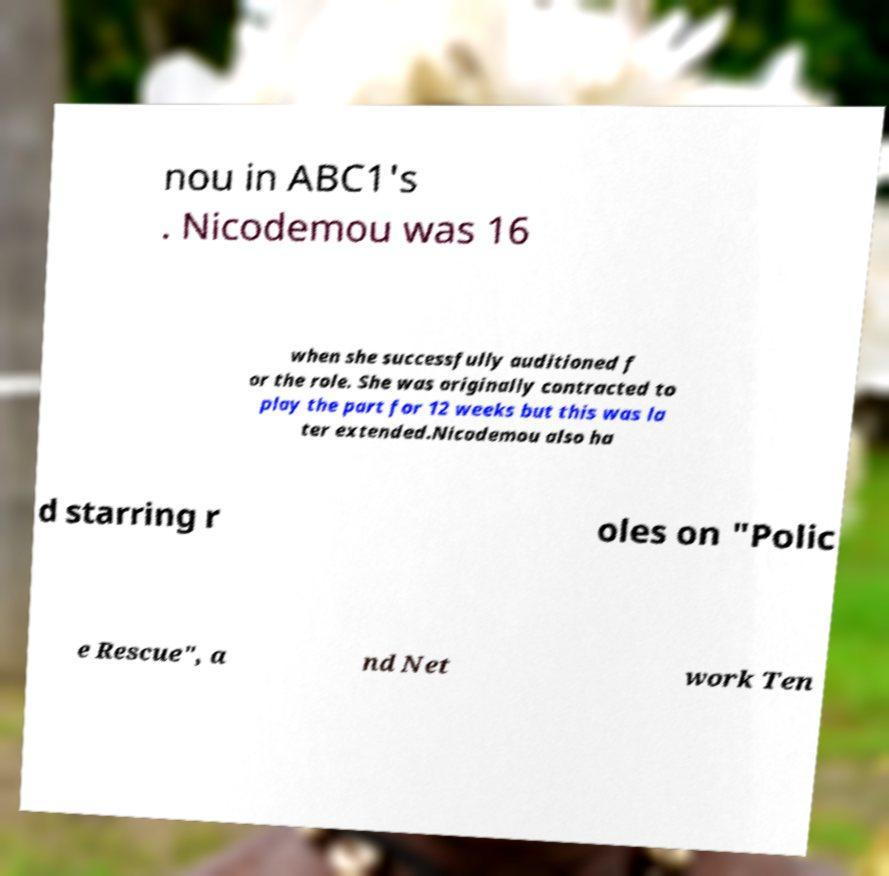Please read and relay the text visible in this image. What does it say? nou in ABC1's . Nicodemou was 16 when she successfully auditioned f or the role. She was originally contracted to play the part for 12 weeks but this was la ter extended.Nicodemou also ha d starring r oles on "Polic e Rescue", a nd Net work Ten 